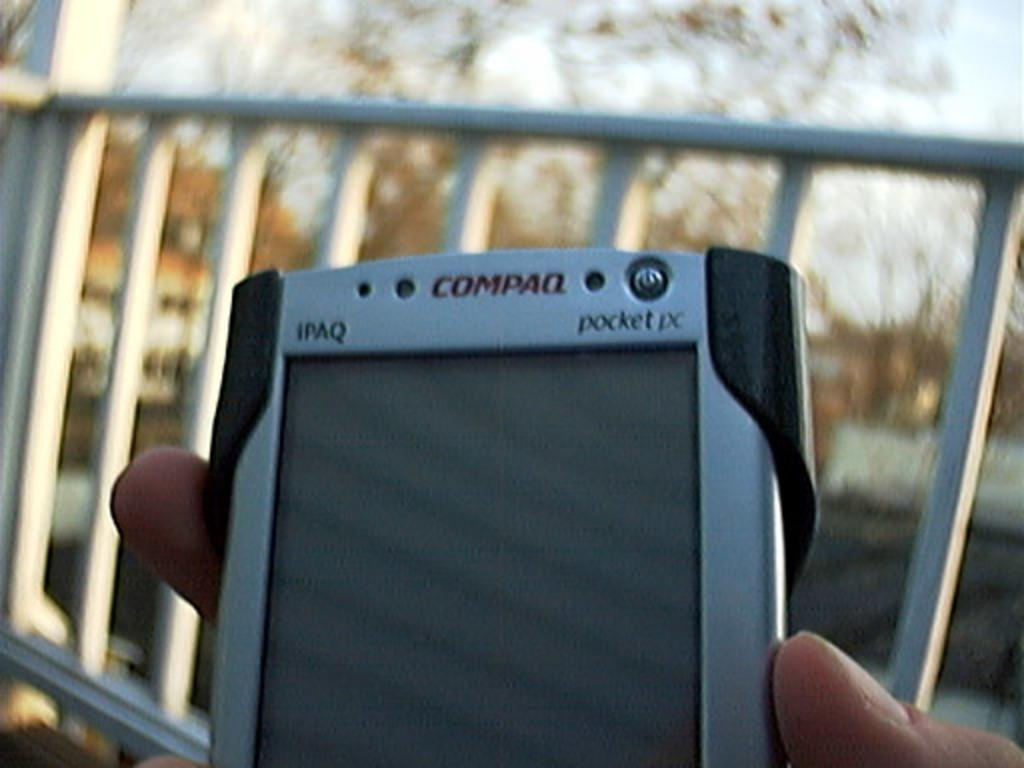What object is the person holding in the image? The person is holding a Compaq mobile phone in the image. What can be seen in the background of the image? There is a fence and trees visible behind the fence in the background of the image. What else is visible in the background of the image? The sky is visible in the background of the image. What message does the person say to the camera before leaving the image? There is no indication in the image that the person is saying good-bye or leaving the scene. 